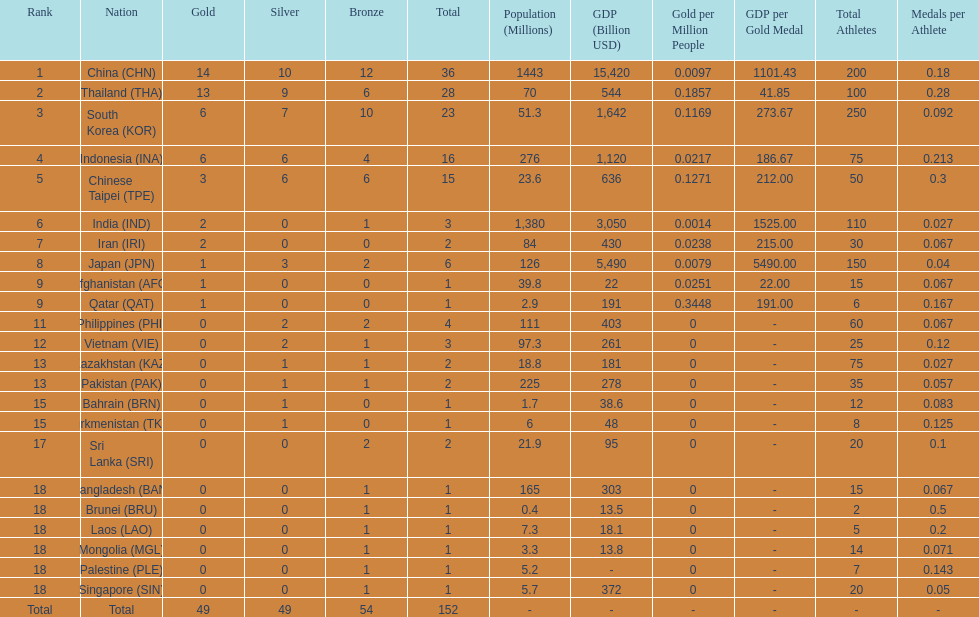How many nations won no silver medals at all? 11. 